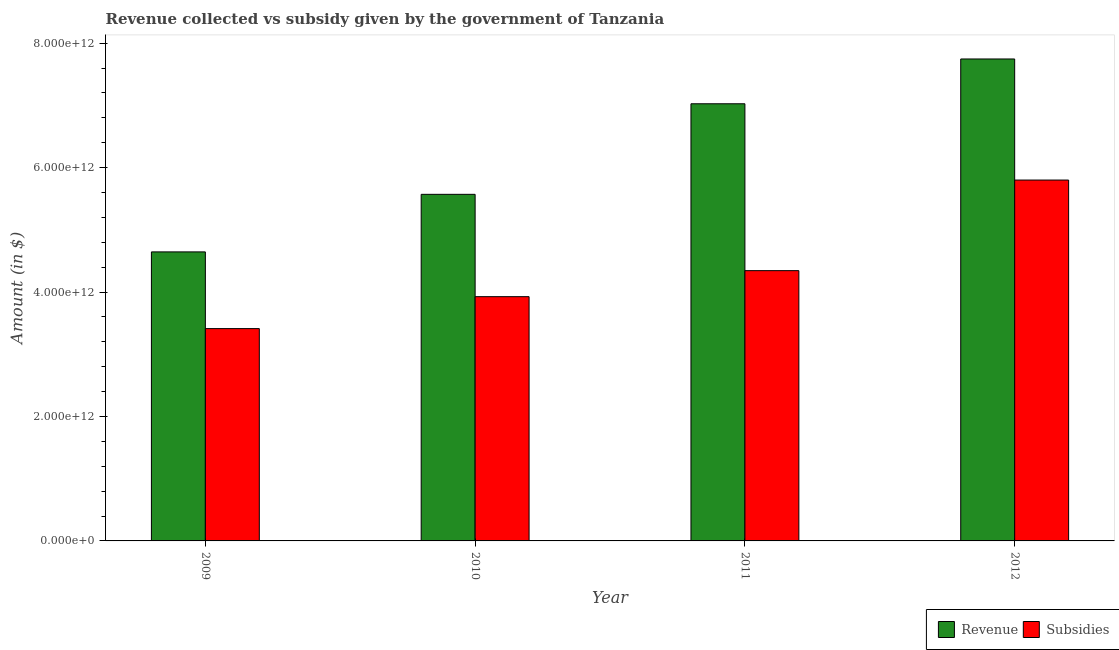Are the number of bars per tick equal to the number of legend labels?
Provide a short and direct response. Yes. Are the number of bars on each tick of the X-axis equal?
Give a very brief answer. Yes. How many bars are there on the 1st tick from the right?
Give a very brief answer. 2. What is the label of the 2nd group of bars from the left?
Offer a very short reply. 2010. In how many cases, is the number of bars for a given year not equal to the number of legend labels?
Keep it short and to the point. 0. What is the amount of revenue collected in 2010?
Provide a succinct answer. 5.57e+12. Across all years, what is the maximum amount of subsidies given?
Make the answer very short. 5.80e+12. Across all years, what is the minimum amount of revenue collected?
Offer a terse response. 4.65e+12. In which year was the amount of revenue collected minimum?
Provide a succinct answer. 2009. What is the total amount of revenue collected in the graph?
Ensure brevity in your answer.  2.50e+13. What is the difference between the amount of revenue collected in 2010 and that in 2012?
Your response must be concise. -2.18e+12. What is the difference between the amount of revenue collected in 2009 and the amount of subsidies given in 2010?
Offer a very short reply. -9.25e+11. What is the average amount of subsidies given per year?
Your answer should be very brief. 4.37e+12. In the year 2011, what is the difference between the amount of revenue collected and amount of subsidies given?
Provide a succinct answer. 0. What is the ratio of the amount of subsidies given in 2009 to that in 2011?
Keep it short and to the point. 0.79. Is the amount of subsidies given in 2010 less than that in 2012?
Keep it short and to the point. Yes. Is the difference between the amount of revenue collected in 2009 and 2011 greater than the difference between the amount of subsidies given in 2009 and 2011?
Give a very brief answer. No. What is the difference between the highest and the second highest amount of subsidies given?
Offer a very short reply. 1.46e+12. What is the difference between the highest and the lowest amount of revenue collected?
Your response must be concise. 3.10e+12. In how many years, is the amount of subsidies given greater than the average amount of subsidies given taken over all years?
Offer a terse response. 1. What does the 1st bar from the left in 2011 represents?
Make the answer very short. Revenue. What does the 1st bar from the right in 2011 represents?
Give a very brief answer. Subsidies. How many bars are there?
Make the answer very short. 8. Are all the bars in the graph horizontal?
Your answer should be compact. No. What is the difference between two consecutive major ticks on the Y-axis?
Provide a succinct answer. 2.00e+12. Does the graph contain grids?
Ensure brevity in your answer.  No. Where does the legend appear in the graph?
Offer a terse response. Bottom right. What is the title of the graph?
Offer a very short reply. Revenue collected vs subsidy given by the government of Tanzania. What is the label or title of the Y-axis?
Provide a short and direct response. Amount (in $). What is the Amount (in $) of Revenue in 2009?
Give a very brief answer. 4.65e+12. What is the Amount (in $) in Subsidies in 2009?
Give a very brief answer. 3.41e+12. What is the Amount (in $) of Revenue in 2010?
Keep it short and to the point. 5.57e+12. What is the Amount (in $) in Subsidies in 2010?
Ensure brevity in your answer.  3.93e+12. What is the Amount (in $) of Revenue in 2011?
Give a very brief answer. 7.03e+12. What is the Amount (in $) of Subsidies in 2011?
Offer a very short reply. 4.34e+12. What is the Amount (in $) of Revenue in 2012?
Give a very brief answer. 7.75e+12. What is the Amount (in $) in Subsidies in 2012?
Give a very brief answer. 5.80e+12. Across all years, what is the maximum Amount (in $) of Revenue?
Offer a terse response. 7.75e+12. Across all years, what is the maximum Amount (in $) in Subsidies?
Give a very brief answer. 5.80e+12. Across all years, what is the minimum Amount (in $) of Revenue?
Offer a very short reply. 4.65e+12. Across all years, what is the minimum Amount (in $) of Subsidies?
Keep it short and to the point. 3.41e+12. What is the total Amount (in $) in Revenue in the graph?
Your response must be concise. 2.50e+13. What is the total Amount (in $) of Subsidies in the graph?
Provide a succinct answer. 1.75e+13. What is the difference between the Amount (in $) of Revenue in 2009 and that in 2010?
Offer a very short reply. -9.25e+11. What is the difference between the Amount (in $) in Subsidies in 2009 and that in 2010?
Ensure brevity in your answer.  -5.13e+11. What is the difference between the Amount (in $) in Revenue in 2009 and that in 2011?
Offer a terse response. -2.38e+12. What is the difference between the Amount (in $) in Subsidies in 2009 and that in 2011?
Offer a terse response. -9.32e+11. What is the difference between the Amount (in $) in Revenue in 2009 and that in 2012?
Make the answer very short. -3.10e+12. What is the difference between the Amount (in $) in Subsidies in 2009 and that in 2012?
Offer a very short reply. -2.39e+12. What is the difference between the Amount (in $) of Revenue in 2010 and that in 2011?
Provide a short and direct response. -1.46e+12. What is the difference between the Amount (in $) in Subsidies in 2010 and that in 2011?
Provide a succinct answer. -4.18e+11. What is the difference between the Amount (in $) in Revenue in 2010 and that in 2012?
Give a very brief answer. -2.18e+12. What is the difference between the Amount (in $) of Subsidies in 2010 and that in 2012?
Your response must be concise. -1.87e+12. What is the difference between the Amount (in $) in Revenue in 2011 and that in 2012?
Offer a very short reply. -7.20e+11. What is the difference between the Amount (in $) of Subsidies in 2011 and that in 2012?
Offer a very short reply. -1.46e+12. What is the difference between the Amount (in $) of Revenue in 2009 and the Amount (in $) of Subsidies in 2010?
Make the answer very short. 7.20e+11. What is the difference between the Amount (in $) in Revenue in 2009 and the Amount (in $) in Subsidies in 2011?
Make the answer very short. 3.01e+11. What is the difference between the Amount (in $) in Revenue in 2009 and the Amount (in $) in Subsidies in 2012?
Your answer should be very brief. -1.15e+12. What is the difference between the Amount (in $) of Revenue in 2010 and the Amount (in $) of Subsidies in 2011?
Your answer should be compact. 1.23e+12. What is the difference between the Amount (in $) of Revenue in 2010 and the Amount (in $) of Subsidies in 2012?
Make the answer very short. -2.29e+11. What is the difference between the Amount (in $) of Revenue in 2011 and the Amount (in $) of Subsidies in 2012?
Make the answer very short. 1.23e+12. What is the average Amount (in $) of Revenue per year?
Your response must be concise. 6.25e+12. What is the average Amount (in $) of Subsidies per year?
Ensure brevity in your answer.  4.37e+12. In the year 2009, what is the difference between the Amount (in $) of Revenue and Amount (in $) of Subsidies?
Your answer should be compact. 1.23e+12. In the year 2010, what is the difference between the Amount (in $) of Revenue and Amount (in $) of Subsidies?
Offer a very short reply. 1.64e+12. In the year 2011, what is the difference between the Amount (in $) in Revenue and Amount (in $) in Subsidies?
Provide a succinct answer. 2.68e+12. In the year 2012, what is the difference between the Amount (in $) in Revenue and Amount (in $) in Subsidies?
Ensure brevity in your answer.  1.95e+12. What is the ratio of the Amount (in $) of Revenue in 2009 to that in 2010?
Make the answer very short. 0.83. What is the ratio of the Amount (in $) in Subsidies in 2009 to that in 2010?
Make the answer very short. 0.87. What is the ratio of the Amount (in $) of Revenue in 2009 to that in 2011?
Provide a short and direct response. 0.66. What is the ratio of the Amount (in $) of Subsidies in 2009 to that in 2011?
Make the answer very short. 0.79. What is the ratio of the Amount (in $) in Revenue in 2009 to that in 2012?
Give a very brief answer. 0.6. What is the ratio of the Amount (in $) in Subsidies in 2009 to that in 2012?
Your response must be concise. 0.59. What is the ratio of the Amount (in $) in Revenue in 2010 to that in 2011?
Provide a succinct answer. 0.79. What is the ratio of the Amount (in $) of Subsidies in 2010 to that in 2011?
Keep it short and to the point. 0.9. What is the ratio of the Amount (in $) in Revenue in 2010 to that in 2012?
Offer a very short reply. 0.72. What is the ratio of the Amount (in $) of Subsidies in 2010 to that in 2012?
Provide a short and direct response. 0.68. What is the ratio of the Amount (in $) in Revenue in 2011 to that in 2012?
Provide a short and direct response. 0.91. What is the ratio of the Amount (in $) in Subsidies in 2011 to that in 2012?
Keep it short and to the point. 0.75. What is the difference between the highest and the second highest Amount (in $) of Revenue?
Provide a succinct answer. 7.20e+11. What is the difference between the highest and the second highest Amount (in $) in Subsidies?
Offer a very short reply. 1.46e+12. What is the difference between the highest and the lowest Amount (in $) of Revenue?
Your response must be concise. 3.10e+12. What is the difference between the highest and the lowest Amount (in $) of Subsidies?
Offer a very short reply. 2.39e+12. 